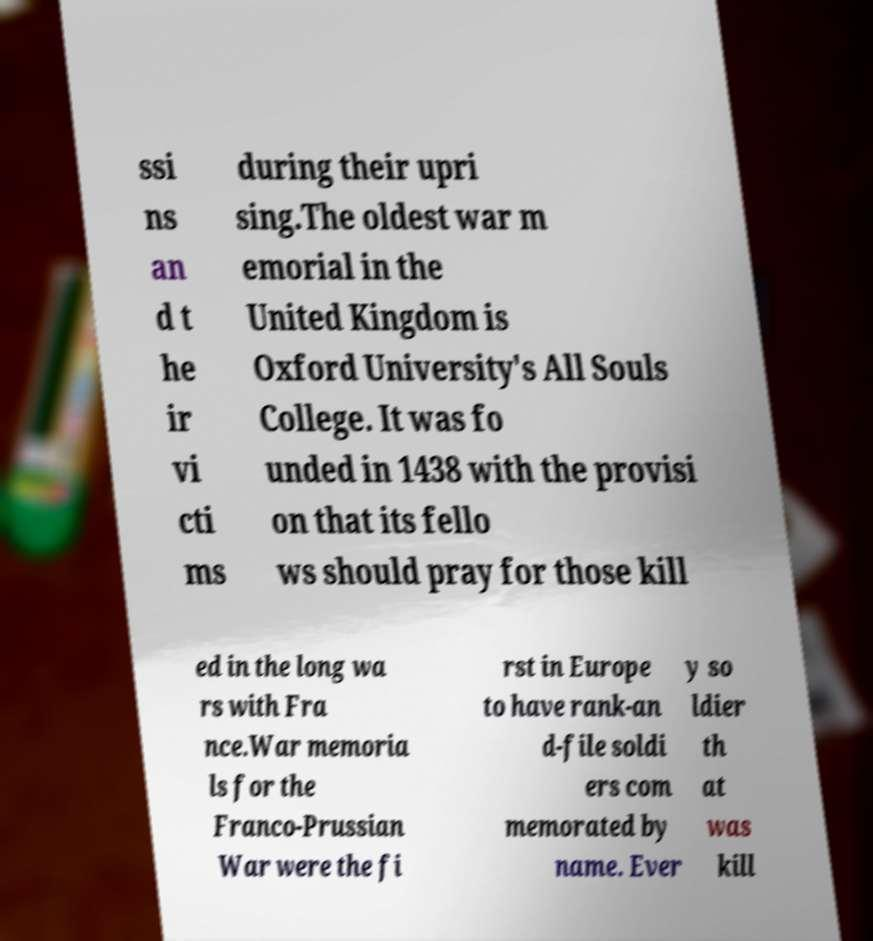I need the written content from this picture converted into text. Can you do that? ssi ns an d t he ir vi cti ms during their upri sing.The oldest war m emorial in the United Kingdom is Oxford University's All Souls College. It was fo unded in 1438 with the provisi on that its fello ws should pray for those kill ed in the long wa rs with Fra nce.War memoria ls for the Franco-Prussian War were the fi rst in Europe to have rank-an d-file soldi ers com memorated by name. Ever y so ldier th at was kill 